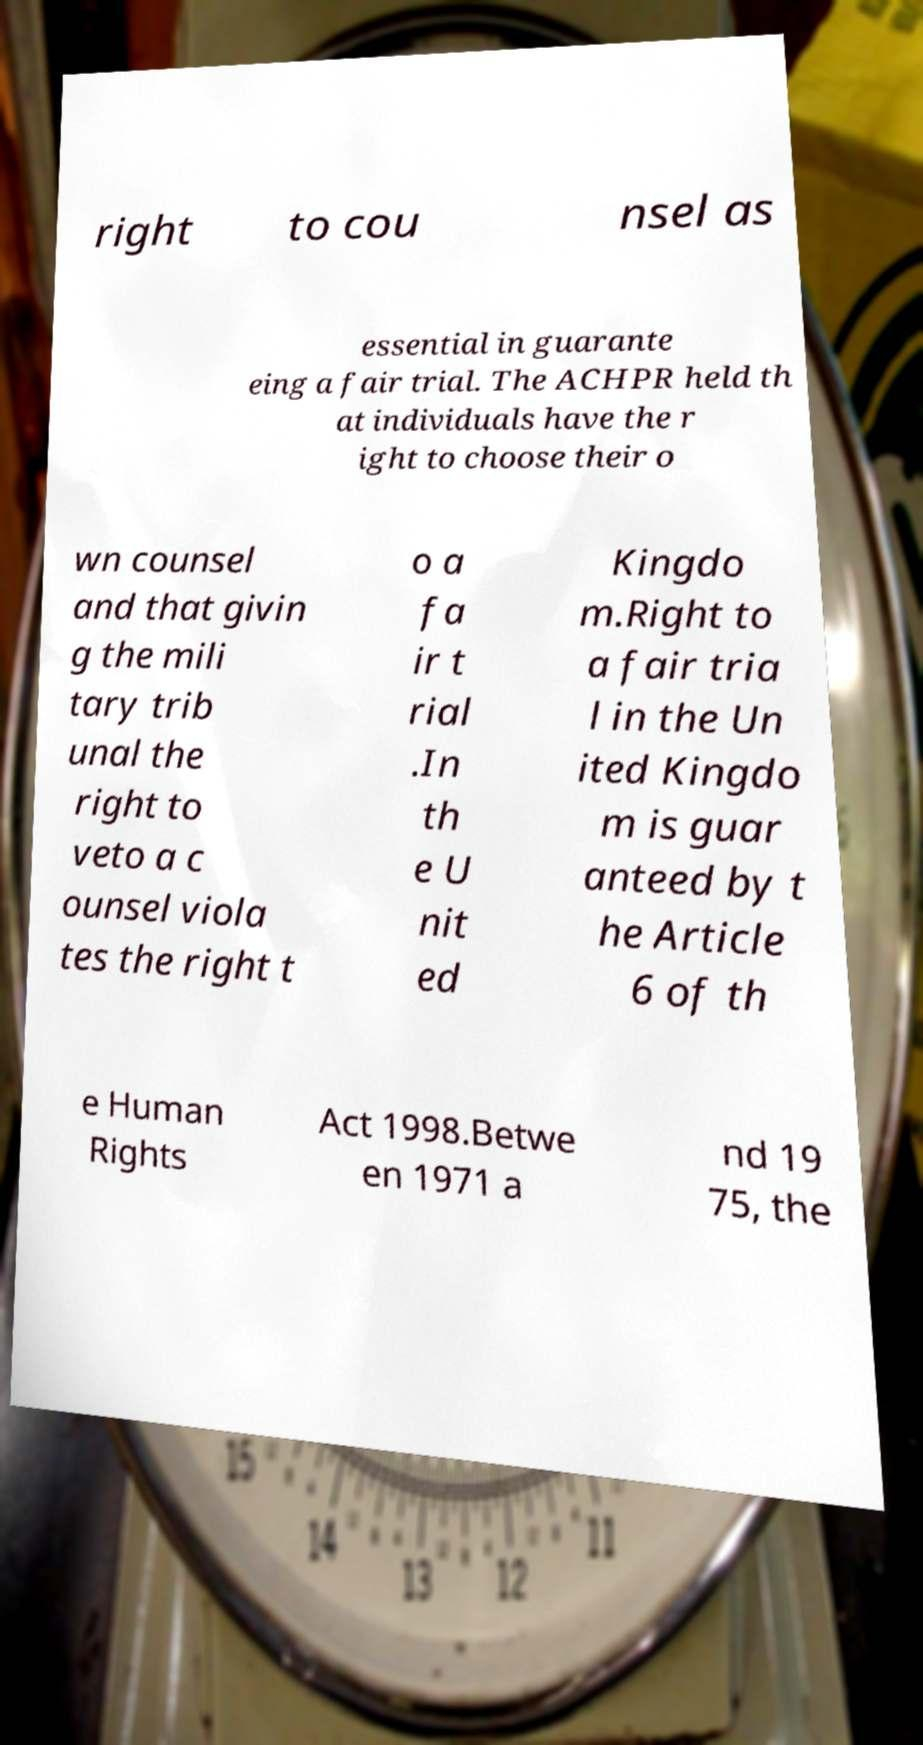Could you extract and type out the text from this image? right to cou nsel as essential in guarante eing a fair trial. The ACHPR held th at individuals have the r ight to choose their o wn counsel and that givin g the mili tary trib unal the right to veto a c ounsel viola tes the right t o a fa ir t rial .In th e U nit ed Kingdo m.Right to a fair tria l in the Un ited Kingdo m is guar anteed by t he Article 6 of th e Human Rights Act 1998.Betwe en 1971 a nd 19 75, the 